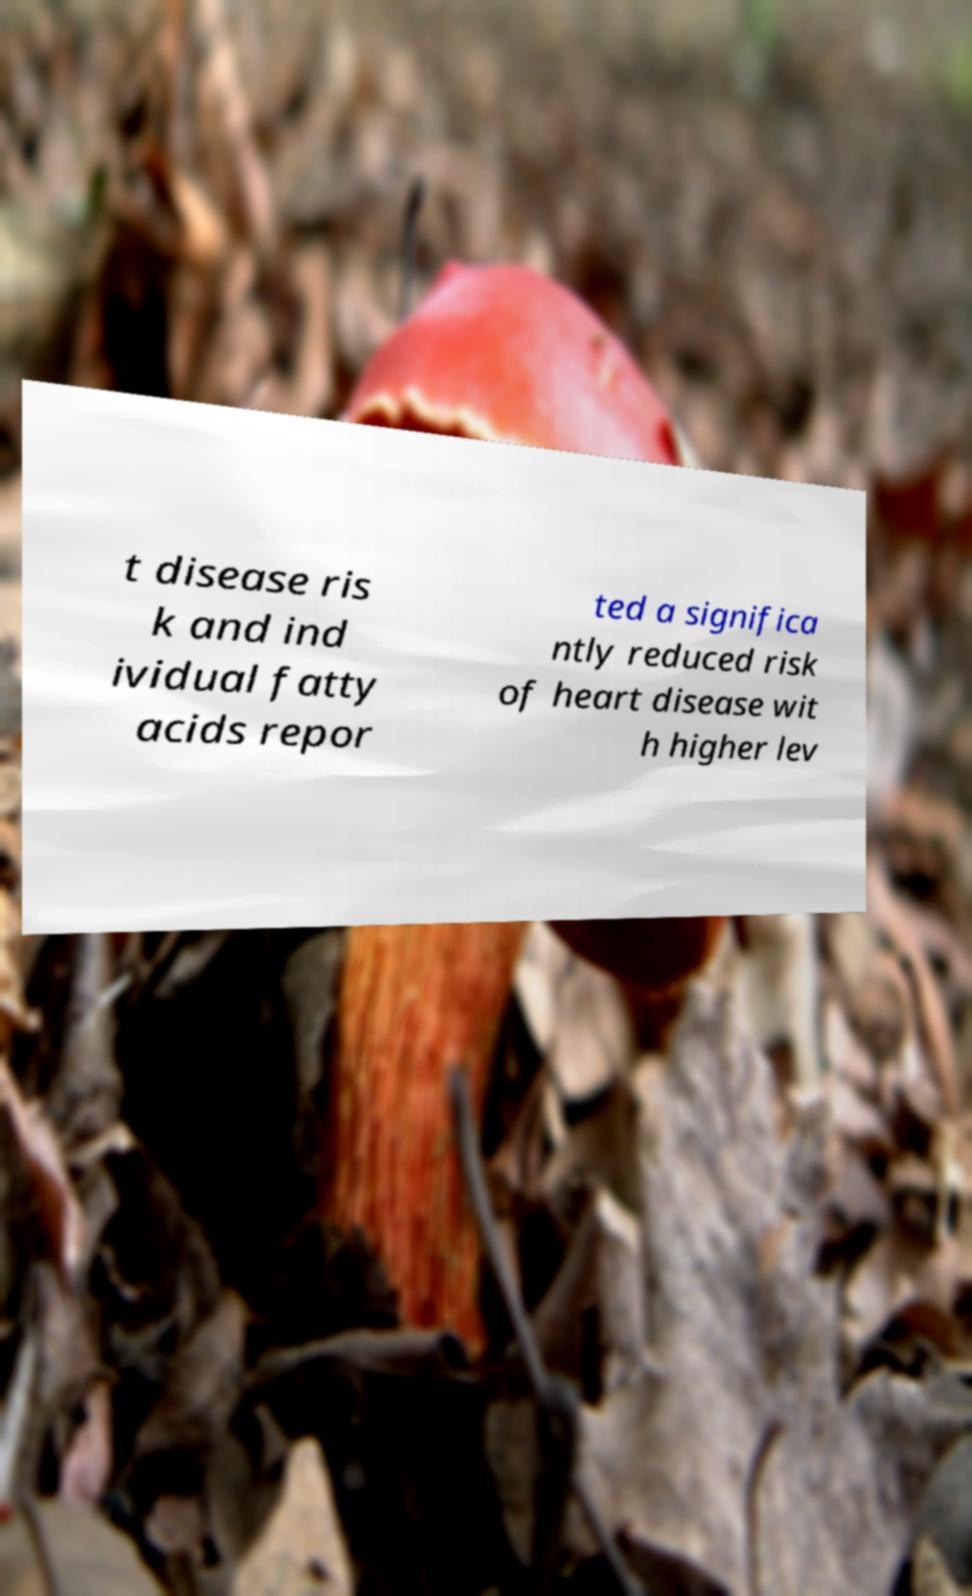Can you read and provide the text displayed in the image?This photo seems to have some interesting text. Can you extract and type it out for me? t disease ris k and ind ividual fatty acids repor ted a significa ntly reduced risk of heart disease wit h higher lev 